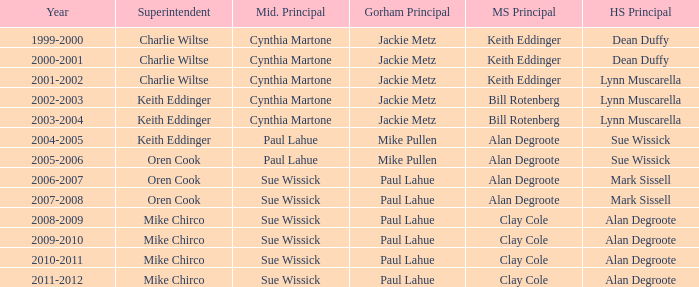How many middlesex principals were there in 2000-2001? 1.0. 